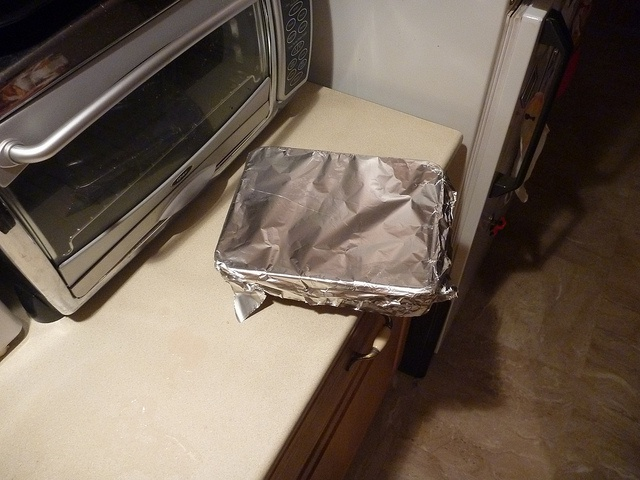Describe the objects in this image and their specific colors. I can see oven in black, gray, and darkgray tones and refrigerator in black, darkgray, and gray tones in this image. 